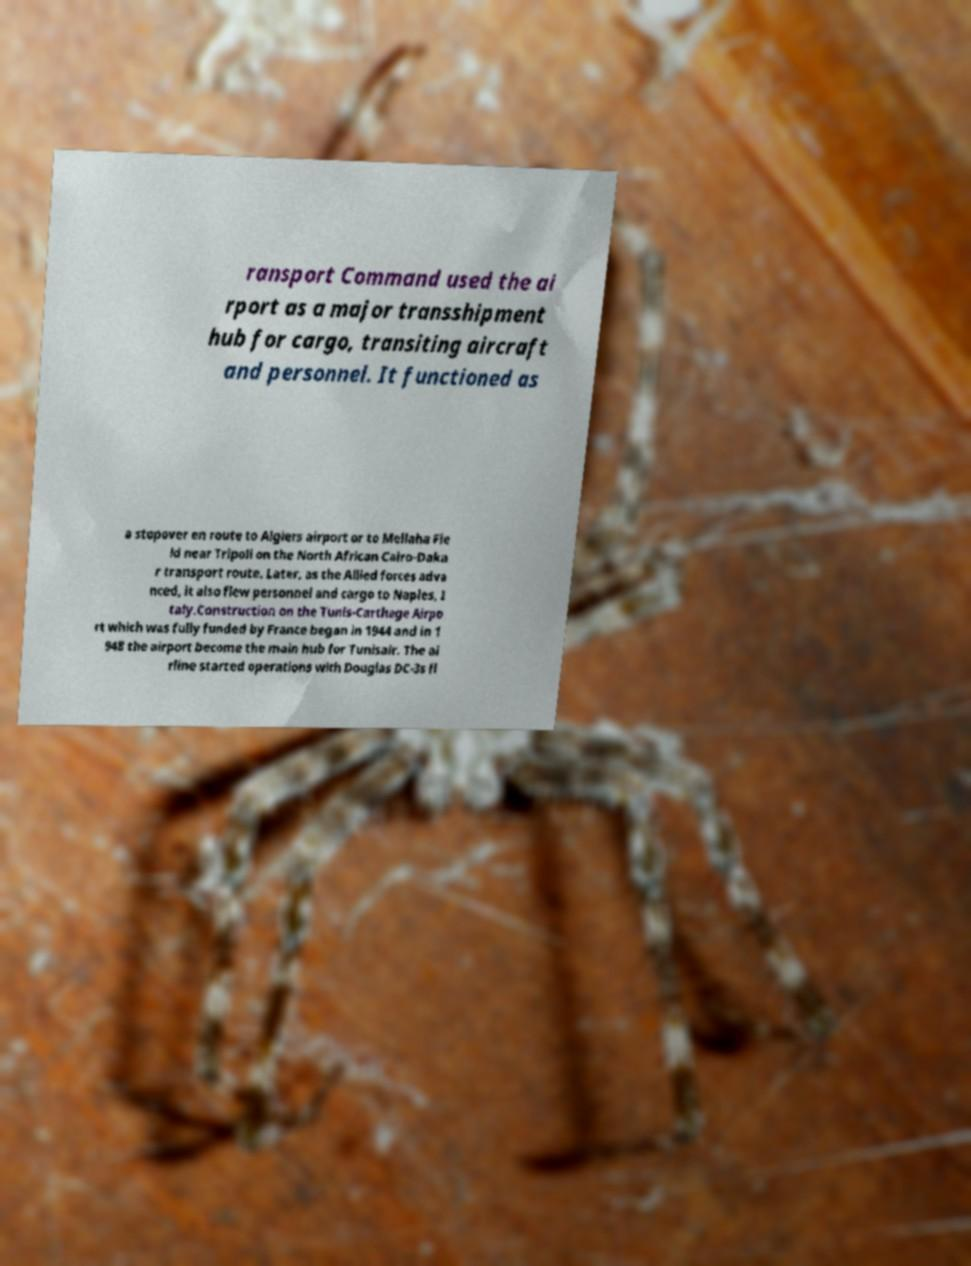For documentation purposes, I need the text within this image transcribed. Could you provide that? ransport Command used the ai rport as a major transshipment hub for cargo, transiting aircraft and personnel. It functioned as a stopover en route to Algiers airport or to Mellaha Fie ld near Tripoli on the North African Cairo-Daka r transport route. Later, as the Allied forces adva nced, it also flew personnel and cargo to Naples, I taly.Construction on the Tunis-Carthage Airpo rt which was fully funded by France began in 1944 and in 1 948 the airport become the main hub for Tunisair. The ai rline started operations with Douglas DC-3s fl 